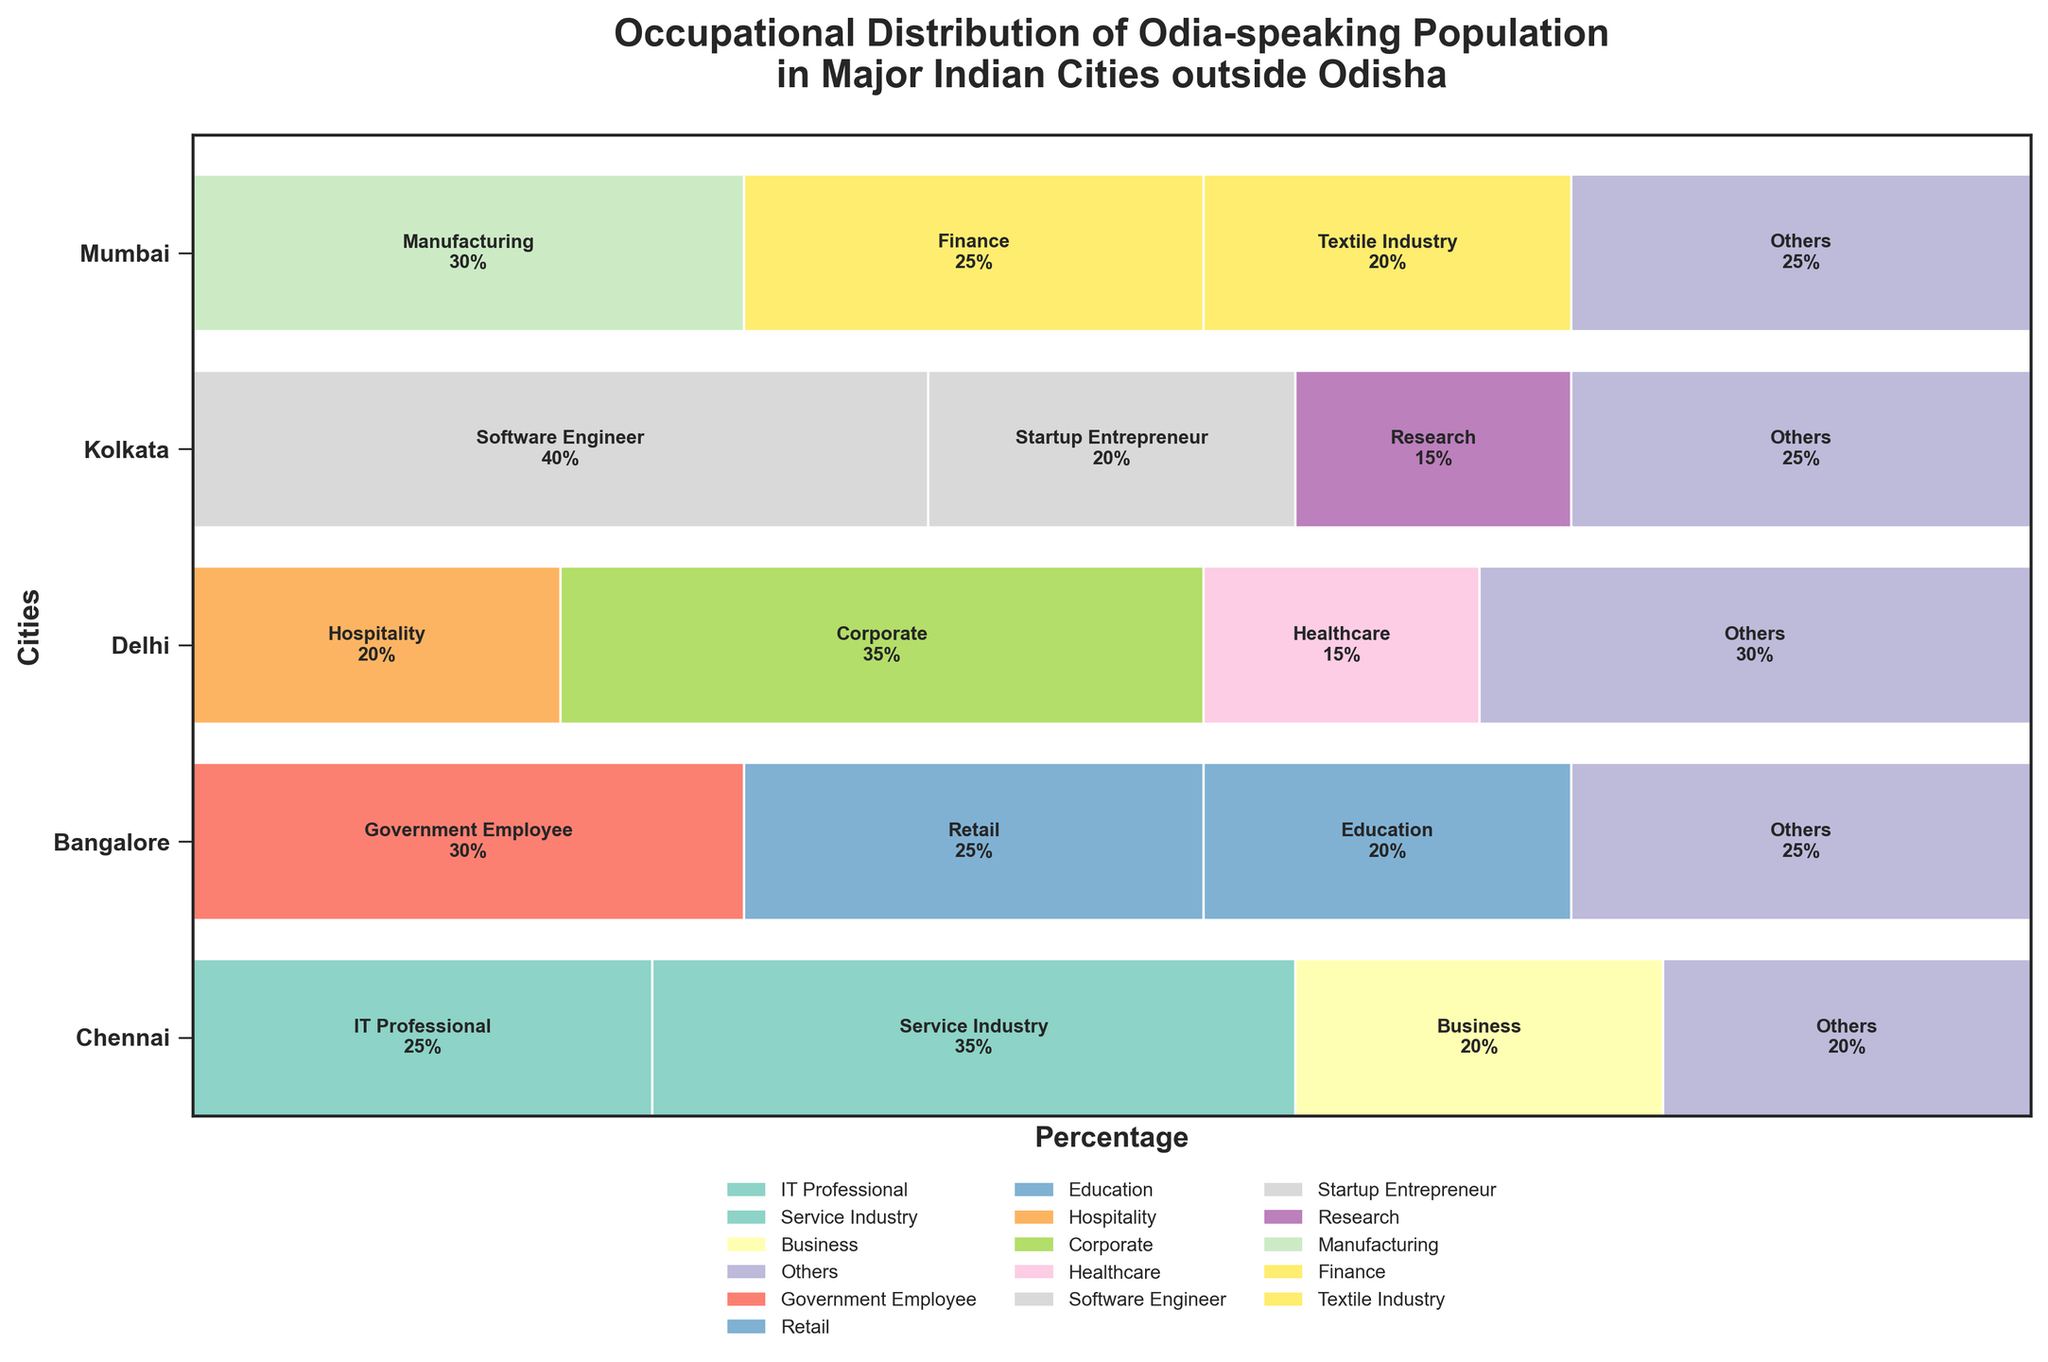what is the title of the figure? The title is usually located at the top of the plot. Here, it states, "Occupational Distribution of Odia-speaking Population in Major Indian Cities outside Odisha".
Answer: Occupational Distribution of Odia-speaking Population in Major Indian Cities outside Odisha Which city has the highest percentage of Odia-speaking IT professionals? By examining the portion labeled "IT Professional" in each city's bar, we see that Mumbai has 25%, which is the highest for this occupation.
Answer: Mumbai What percentage of Odia-speaking population in Delhi works in Hospitality? Looking at Delhi's segment labeled "Hospitality," we see it is 20%.
Answer: 20% How many different occupation categories are presented in the plot? By counting the unique labels within each city's section, we see there are 16 different occupation categories.
Answer: 16 Which city has the largest variety of occupations for Odia-speaking people? Counting the unique occupations in each city's bar, Mumbai has 4, Kolkata has 4, Delhi has 4, Bangalore has 4, and Chennai has 4. Each city has an equal variety.
Answer: All cities have an equal variety What occupation has the lowest representation in Bangalore? By comparing the sizes of the segments for Bangalore, the smallest segment is "Research" with 15%.
Answer: Research Compare the percentage of Odia-speaking population in government jobs between Mumbai and Kolkata. In Mumbai, there isn't a segment for "Government Employee," but Kolkata's segment for "Government Employee" is 30%. So, Kolkata has a higher percentage.
Answer: Kolkata What is the combined percentage of Odia-speaking Business and Service Industry workers in Mumbai? In Mumbai, Business is 20% and Service Industry is 35%. Adding these gives 20% + 35% = 55%.
Answer: 55% Which occupation has the highest representation across all cities? By looking at the largest segments in each city, "Software Engineer" in Bangalore stands out with 40%.
Answer: Software Engineer Compare the "Others" category across all cities. Which city has the highest percentage in this category? The "Others" segments are as follows: Mumbai 20%, Kolkata 25%, Delhi 30%, Bangalore 25%, Chennai 25%. Delhi has the highest percentage.
Answer: Delhi 